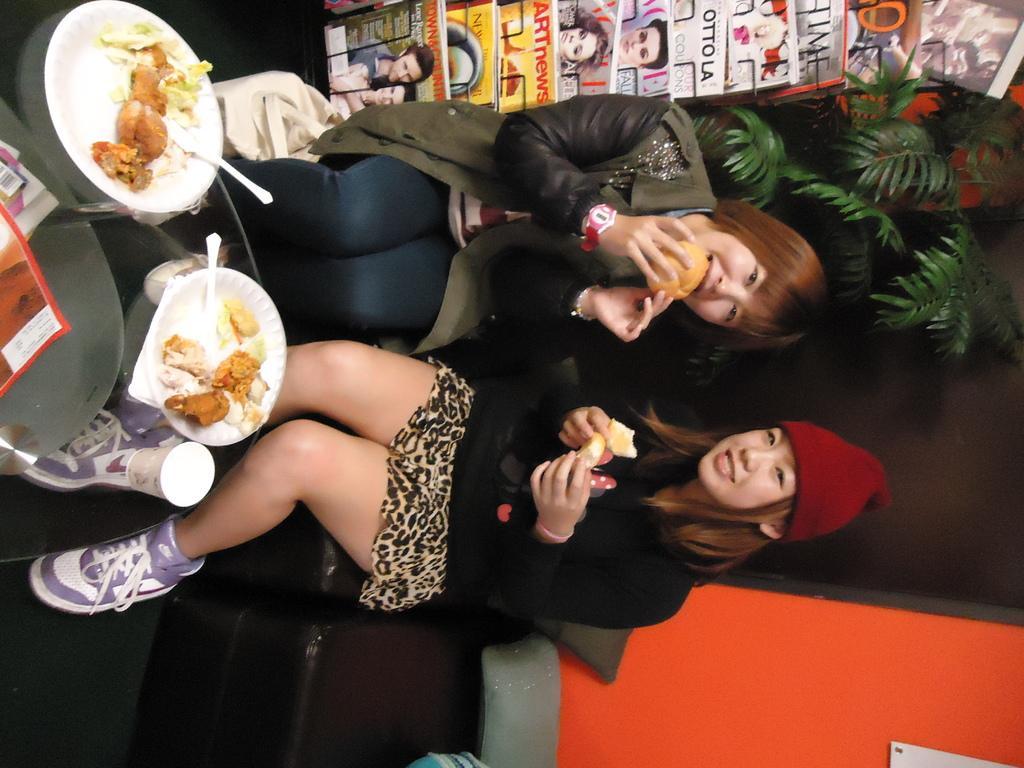Describe this image in one or two sentences. There are two women sitting on the chair and holding food item in their hands. On the table there are food items in two plates. In the background there are books in a stand,bag,house plant and a wall. 